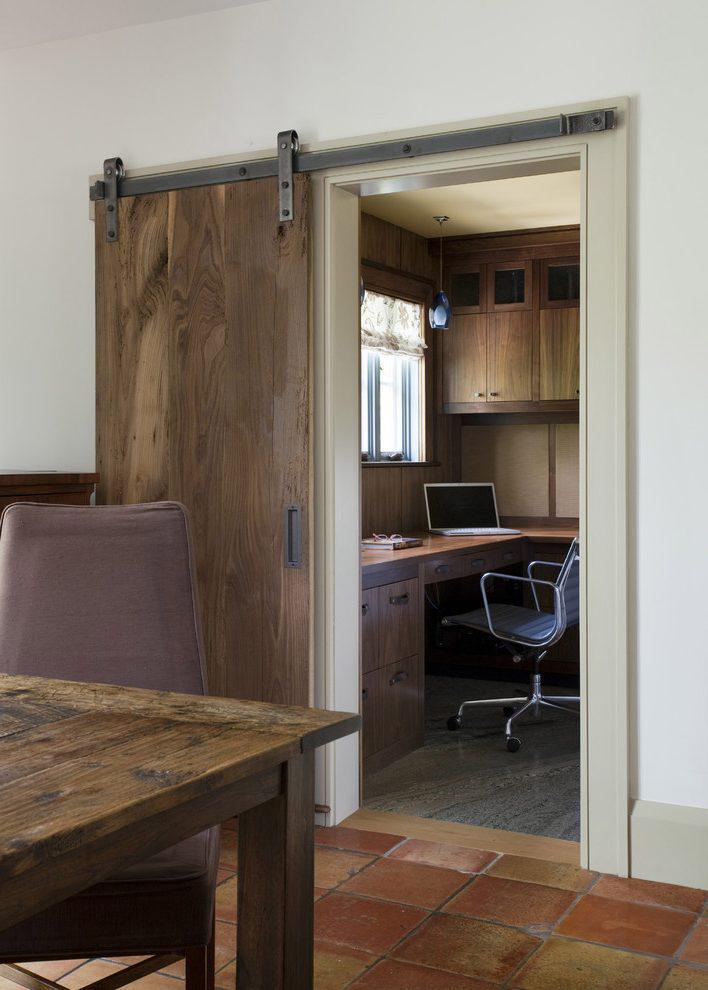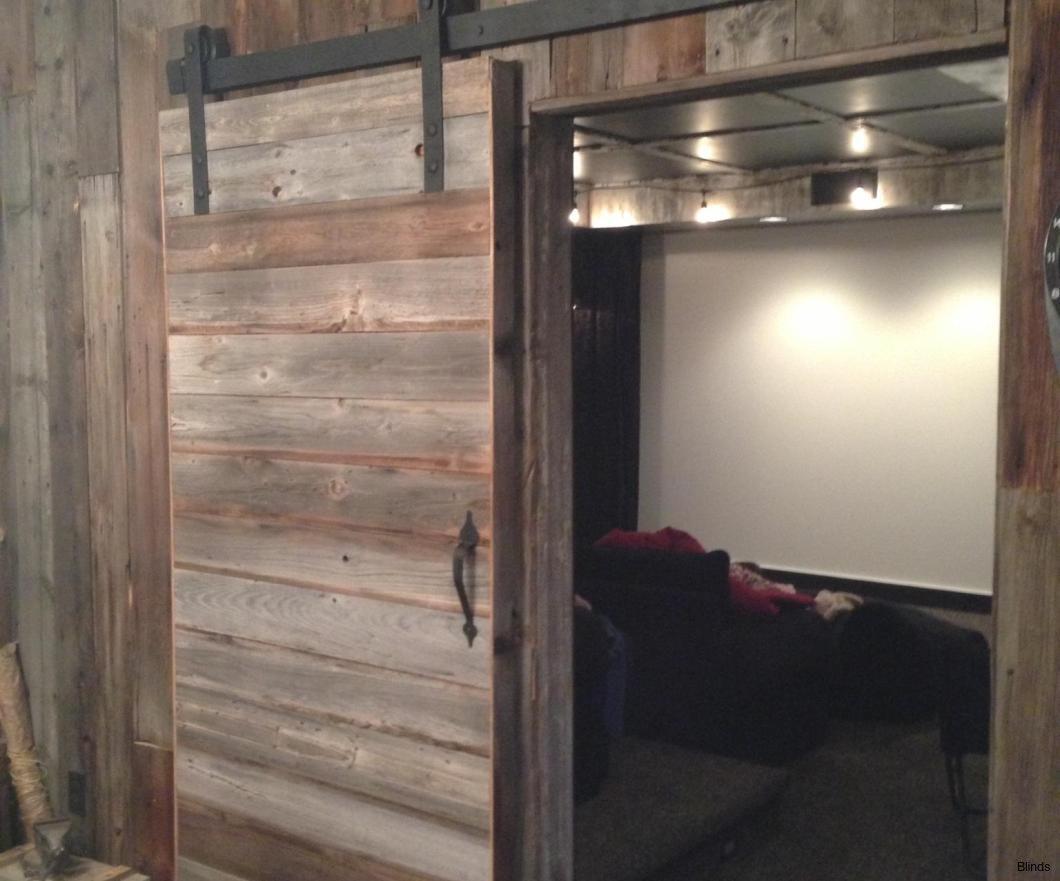The first image is the image on the left, the second image is the image on the right. Analyze the images presented: Is the assertion "THere is a total of two hanging doors." valid? Answer yes or no. Yes. The first image is the image on the left, the second image is the image on the right. For the images shown, is this caption "One door is open in the center, the other is open to the side." true? Answer yes or no. No. 